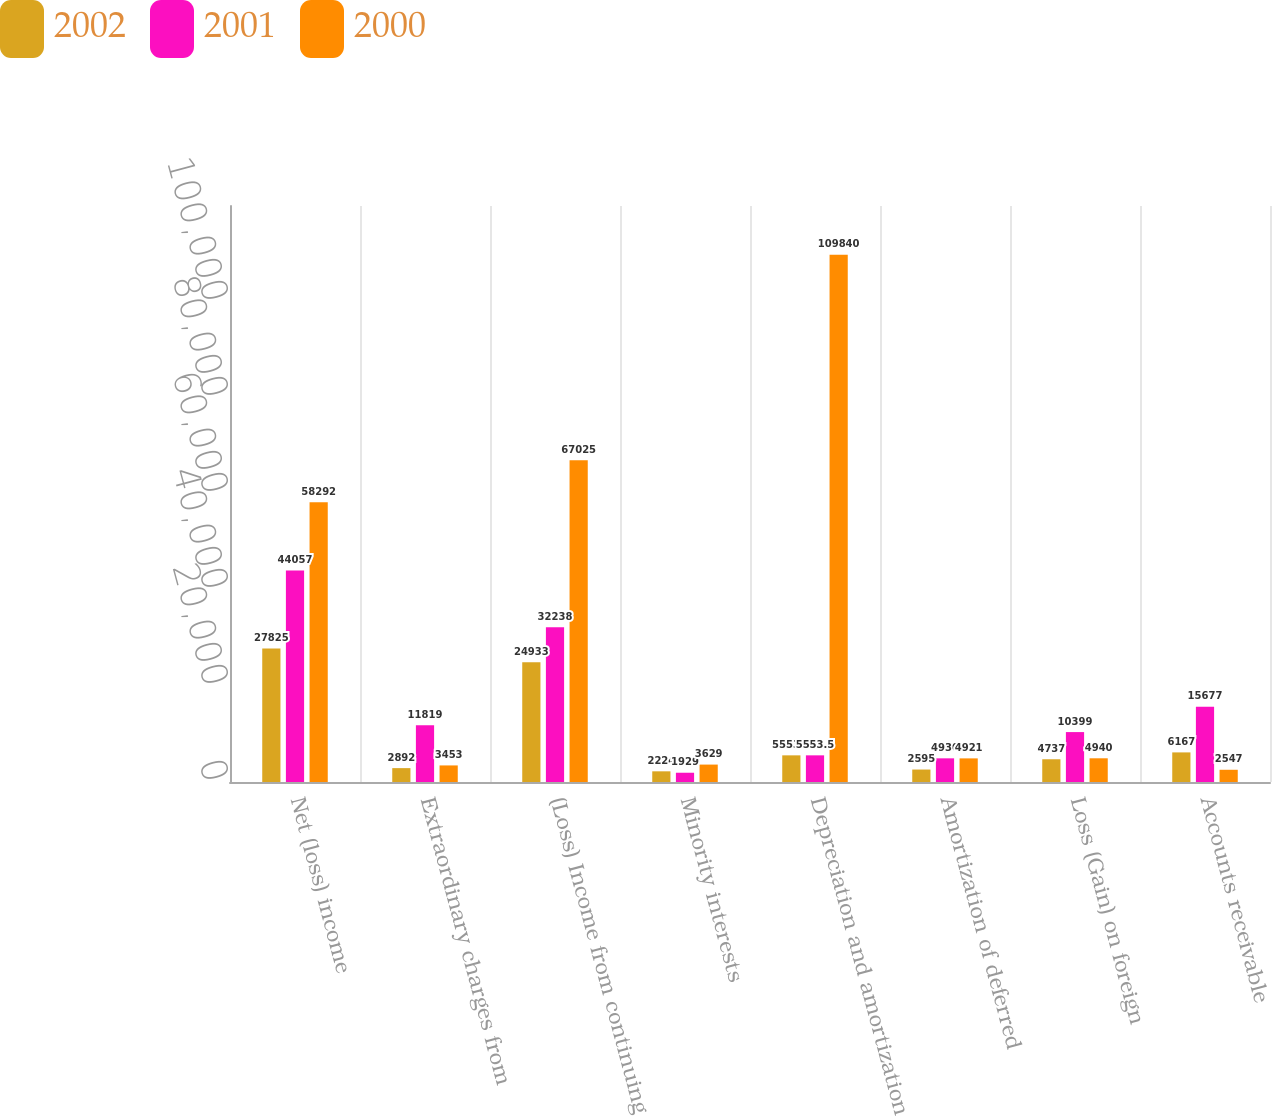Convert chart to OTSL. <chart><loc_0><loc_0><loc_500><loc_500><stacked_bar_chart><ecel><fcel>Net (loss) income<fcel>Extraordinary charges from<fcel>(Loss) Income from continuing<fcel>Minority interests<fcel>Depreciation and amortization<fcel>Amortization of deferred<fcel>Loss (Gain) on foreign<fcel>Accounts receivable<nl><fcel>2002<fcel>27825<fcel>2892<fcel>24933<fcel>2224<fcel>5553.5<fcel>2595<fcel>4737<fcel>6167<nl><fcel>2001<fcel>44057<fcel>11819<fcel>32238<fcel>1929<fcel>5553.5<fcel>4930<fcel>10399<fcel>15677<nl><fcel>2000<fcel>58292<fcel>3453<fcel>67025<fcel>3629<fcel>109840<fcel>4921<fcel>4940<fcel>2547<nl></chart> 